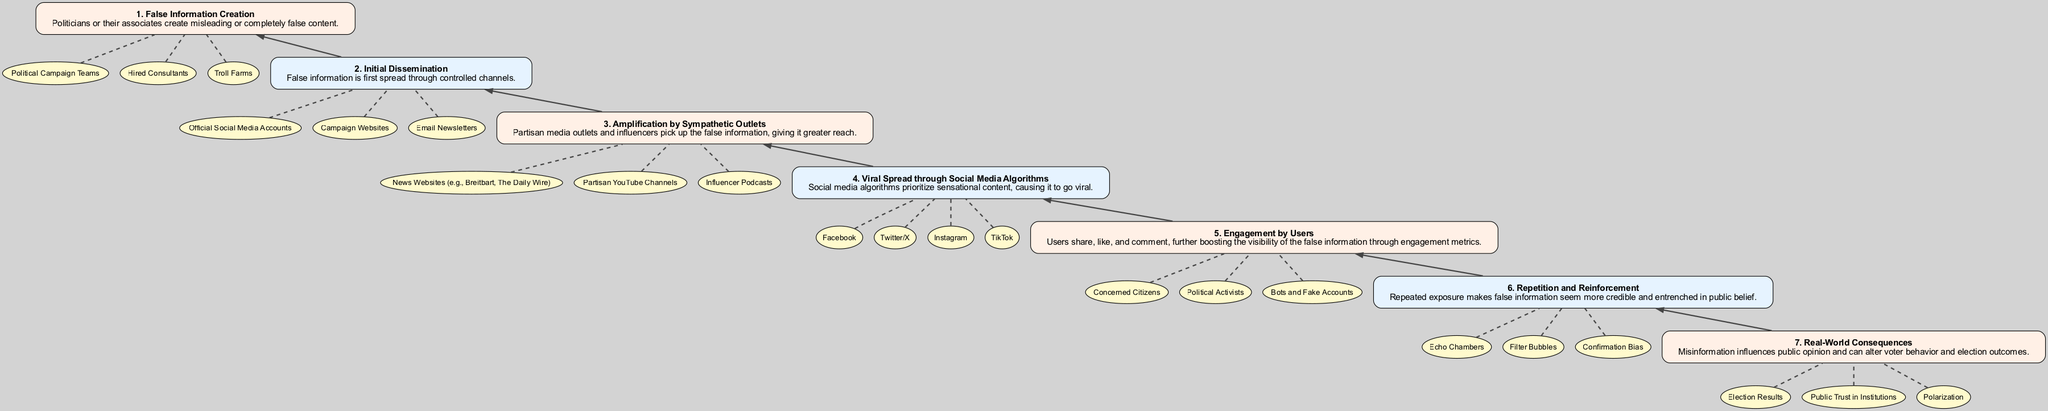What is the first step in the misinformation flow? The first node in the flow chart is labeled "1. False Information Creation". It represents the initial action that triggers the subsequent steps of misinformation spreading.
Answer: False Information Creation How many entities are associated with the "Viral Spread through Social Media Algorithms" step? In the flow chart, step 4 has 4 associated entities: Facebook, Twitter/X, Instagram, and TikTok. There are 4 entities listed under this step.
Answer: 4 What step comes directly after "Engagement by Users"? Looking at the flow upwards, "Engagement by Users" is step 5, and directly above it is "Repetition and Reinforcement," which is step 6. Therefore, the step that comes next is "Repetition and Reinforcement".
Answer: Repetition and Reinforcement Which step involves the creation of false content? The diagram begins with "1. False Information Creation," making it clear this step represents the initial creation of misleading or false content before any dissemination occurs.
Answer: False Information Creation What are the real-world consequences mentioned in the diagram? At the top of the diagram, in the last step, "7. Real-World Consequences" highlights the impacts of misinformation, which include "Election Results," "Public Trust in Institutions," and "Polarization".
Answer: Election Results, Public Trust in Institutions, Polarization Explain how misinformation starts to spread after initial dissemination. After "Initial Dissemination," which is step 2, the false information is picked up by "Amplification by Sympathetic Outlets," which is step 3. This means that the misinformation starts being circulated by others who are sympathetic to the message, increasing its visibility.
Answer: Amplification by Sympathetic Outlets How is "Viral Spread through Social Media Algorithms" facilitated? The flow indicates that this step is contingent upon sensational content prioritization by social media algorithms, which can cause information to go viral. Hence, this step details the mechanism leading to widespread exposure.
Answer: Through sensational content prioritization What effect does "Repetition and Reinforcement" have on misinformation? This step indicates that repeated exposure to misinformation leads to increased credibility in the public’s perception, making it seem more believable and entrenched, thus affecting people's beliefs significantly.
Answer: Increases perceived credibility What role do "Concerned Citizens" play in spreading misinformation? In the step "5. Engagement by Users," "Concerned Citizens" are listed as part of the entities that interact with the misinformation by sharing, liking, and commenting, which increases its visibility through engagement metrics.
Answer: They share, like, and comment on misinformation 